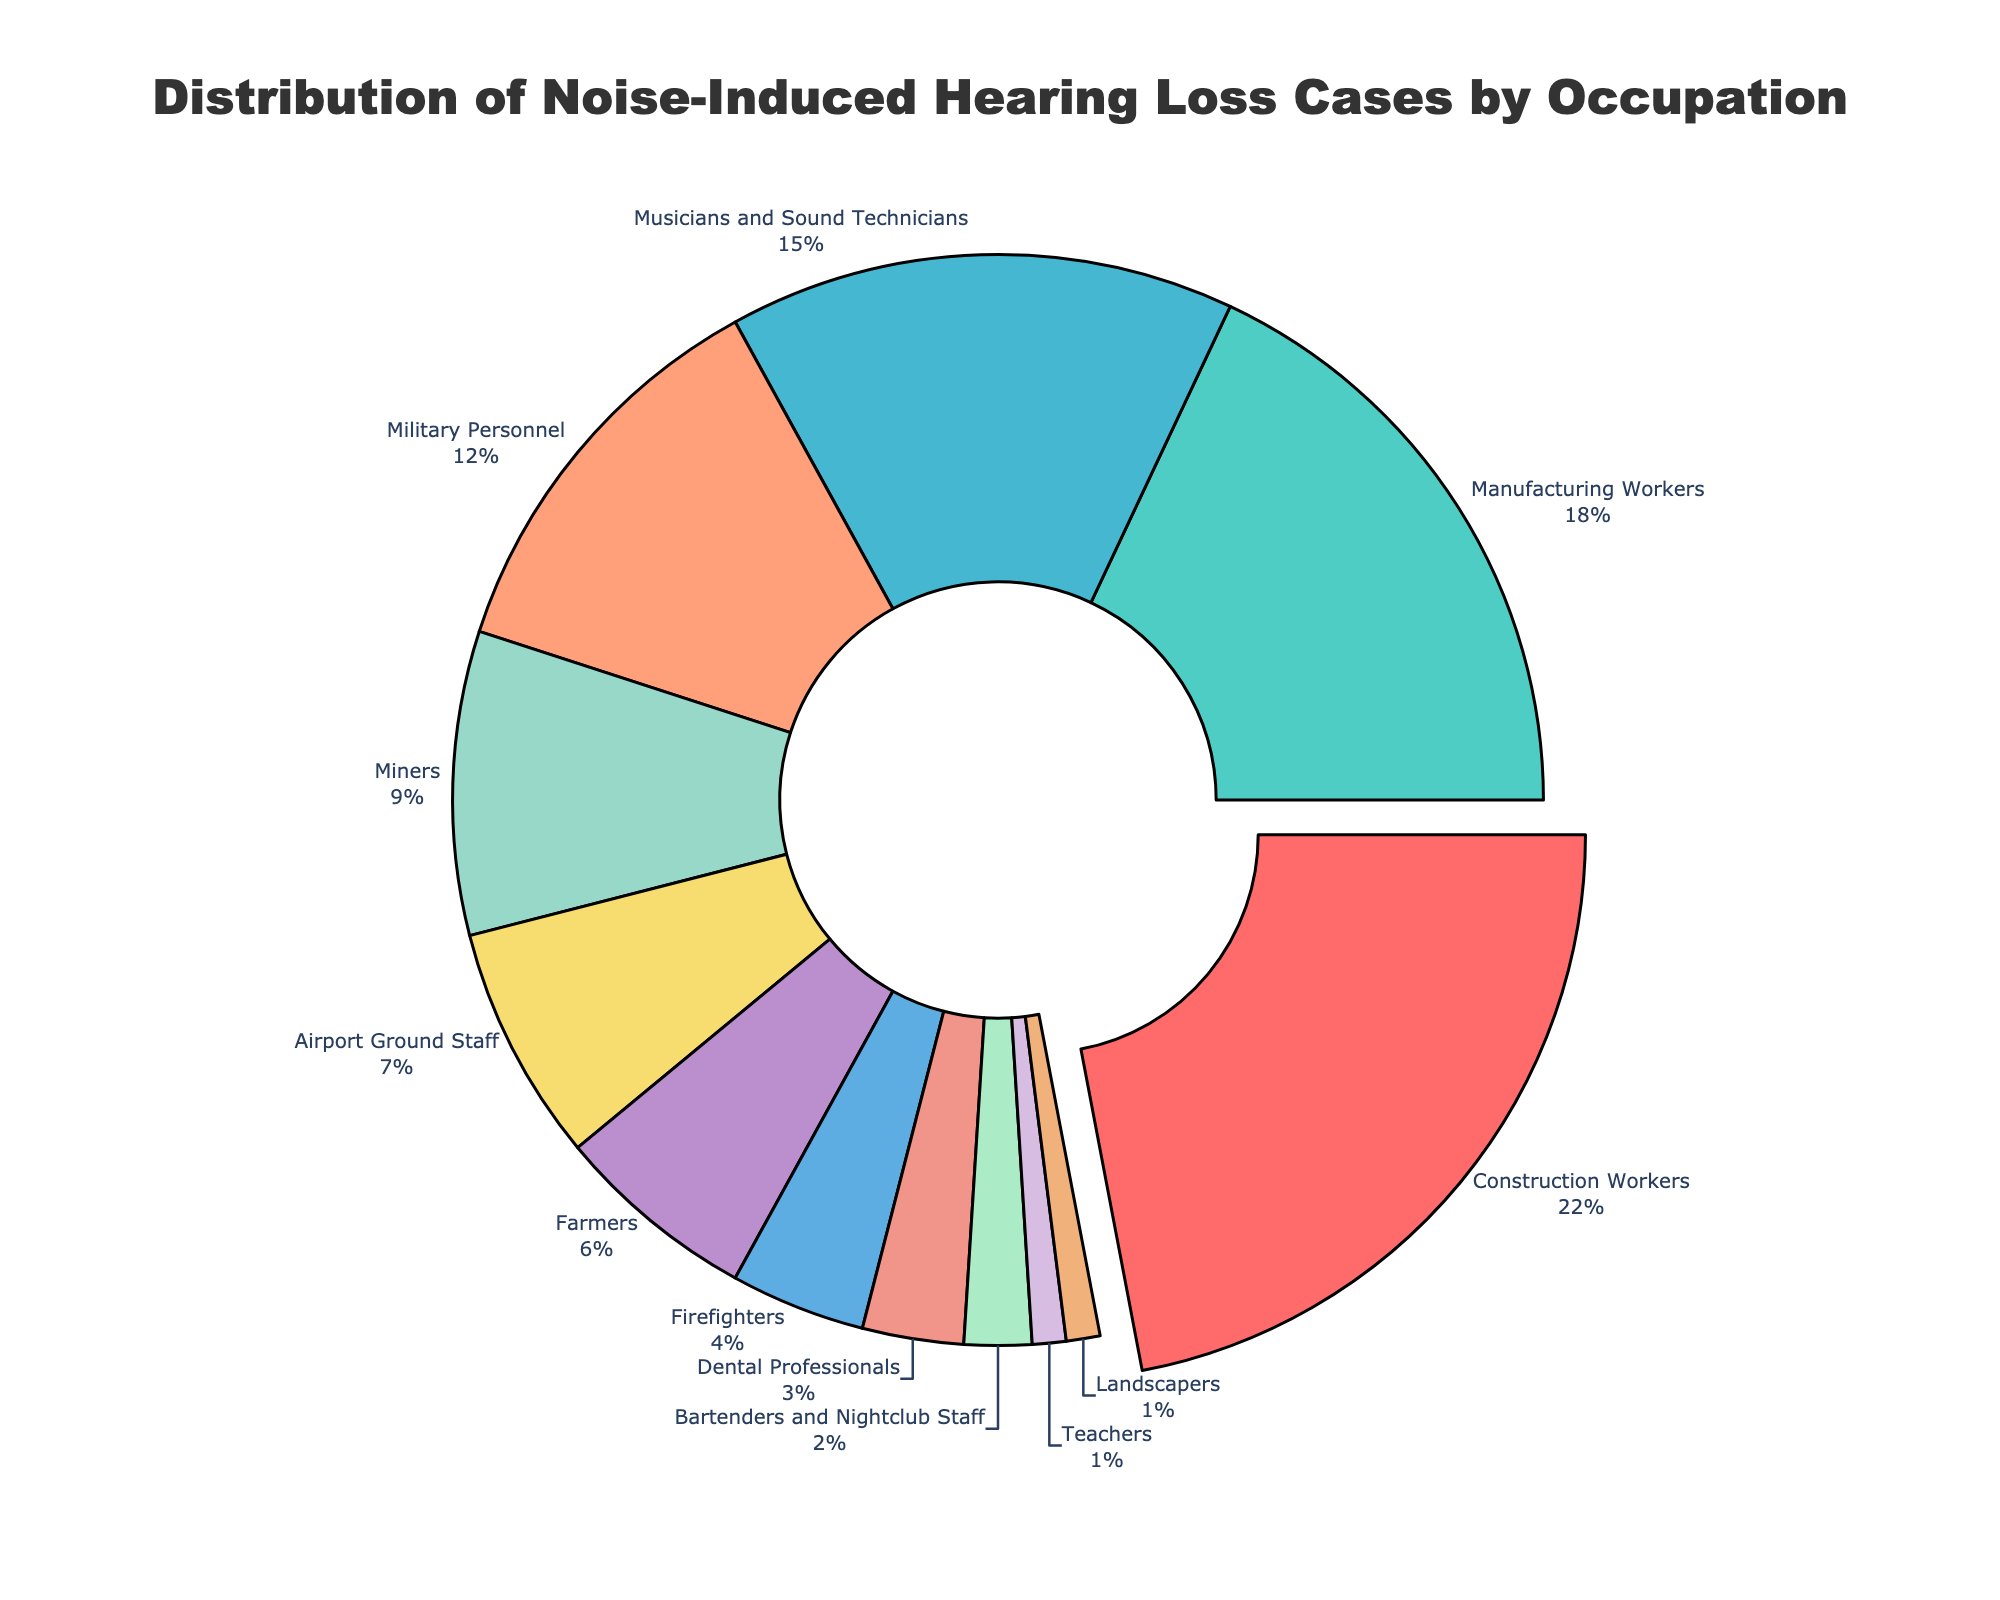Which occupation has the highest percentage of noise-induced hearing loss cases? The chart shows the occupations and their corresponding percentages. The slice for Construction Workers is pulled out, indicating it has the highest percentage.
Answer: Construction Workers Compare the percentage of noise-induced hearing loss cases between Construction Workers and Teachers. The chart lists Construction Workers with 22% and Teachers with 1%. 22% is significantly higher than 1%.
Answer: Construction Workers have a higher percentage What is the combined percentage of noise-induced hearing loss cases for Musicians and Sound Technicians, and Military Personnel? Musicians and Sound Technicians have 15%, and Military Personnel have 12%. Adding these together gives 15% + 12% = 27%.
Answer: 27% Which occupation has a lower percentage of noise-induced hearing loss cases: Farmers or Airport Ground Staff? The chart shows Farmers with 6% and Airport Ground Staff with 7%. 6% is less than 7%.
Answer: Farmers How many occupations have a percentage of noise-induced hearing loss cases above 10%? The chart shows Construction Workers (22%), Manufacturing Workers (18%), Musicians and Sound Technicians (15%), and Military Personnel (12%) all above 10%. That's 4 occupations.
Answer: 4 What is the percentage difference between Manufacturing Workers and Bartenders and Nightclub Staff? Manufacturing Workers have 18%, and Bartenders and Nightclub Staff have 2%. The difference is 18% - 2% = 16%.
Answer: 16% Identify the occupation with the least percentage of noise-induced hearing loss cases. Teachers and Landscapers both have 1%, which are the lowest percentages shown in the chart.
Answer: Teachers, Landscapers Which occupation has a percentage closest to 5%? The chart shows that Firefighters have 4% and Farmers have 6%. 4% is closer to 5% than 6%.
Answer: Firefighters What is the average percentage of noise-induced hearing loss cases for Dental Professionals, Bartenders and Nightclub Staff, and Teachers? Dental Professionals have 3%, Bartenders and Nightclub Staff have 2%, and Teachers have 1%. The average is (3% + 2% + 1%) / 3 = 2%.
Answer: 2% Compare the noise-induced hearing loss cases between Miners and Firefighters. Miners have 9%, and Firefighters have 4%. 9% is greater than 4%.
Answer: Miners have a higher percentage 